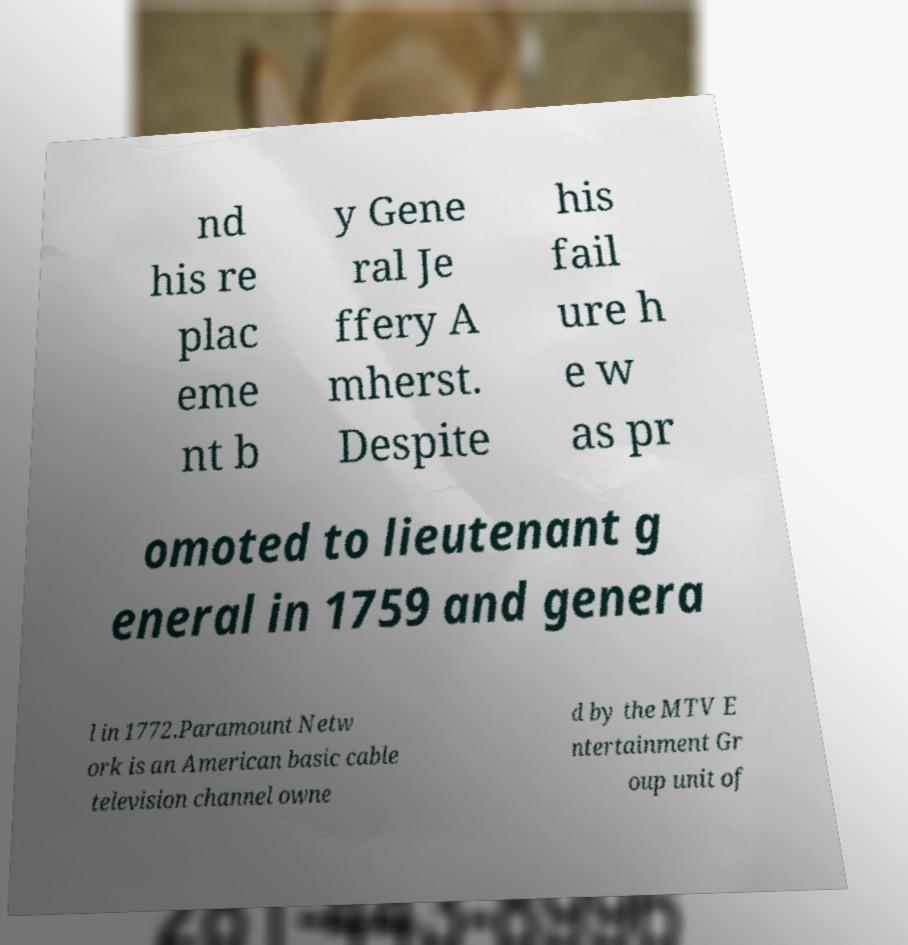There's text embedded in this image that I need extracted. Can you transcribe it verbatim? nd his re plac eme nt b y Gene ral Je ffery A mherst. Despite his fail ure h e w as pr omoted to lieutenant g eneral in 1759 and genera l in 1772.Paramount Netw ork is an American basic cable television channel owne d by the MTV E ntertainment Gr oup unit of 